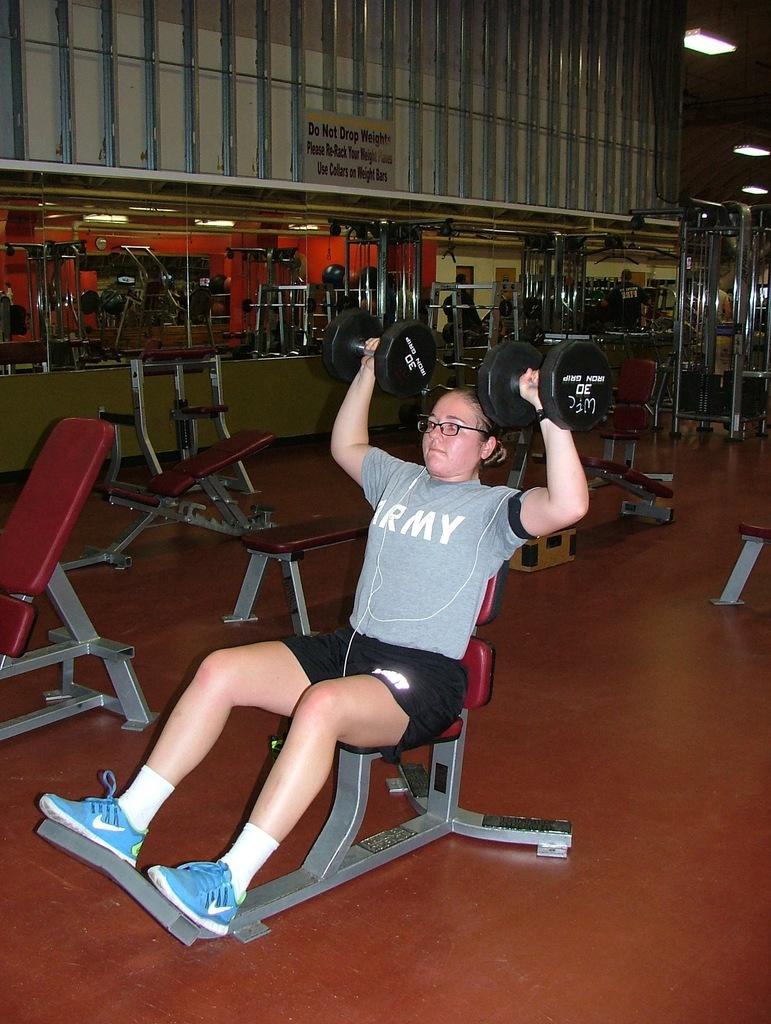Please provide a concise description of this image. A woman is sitting on the chair lifting weights, this is mirror. 